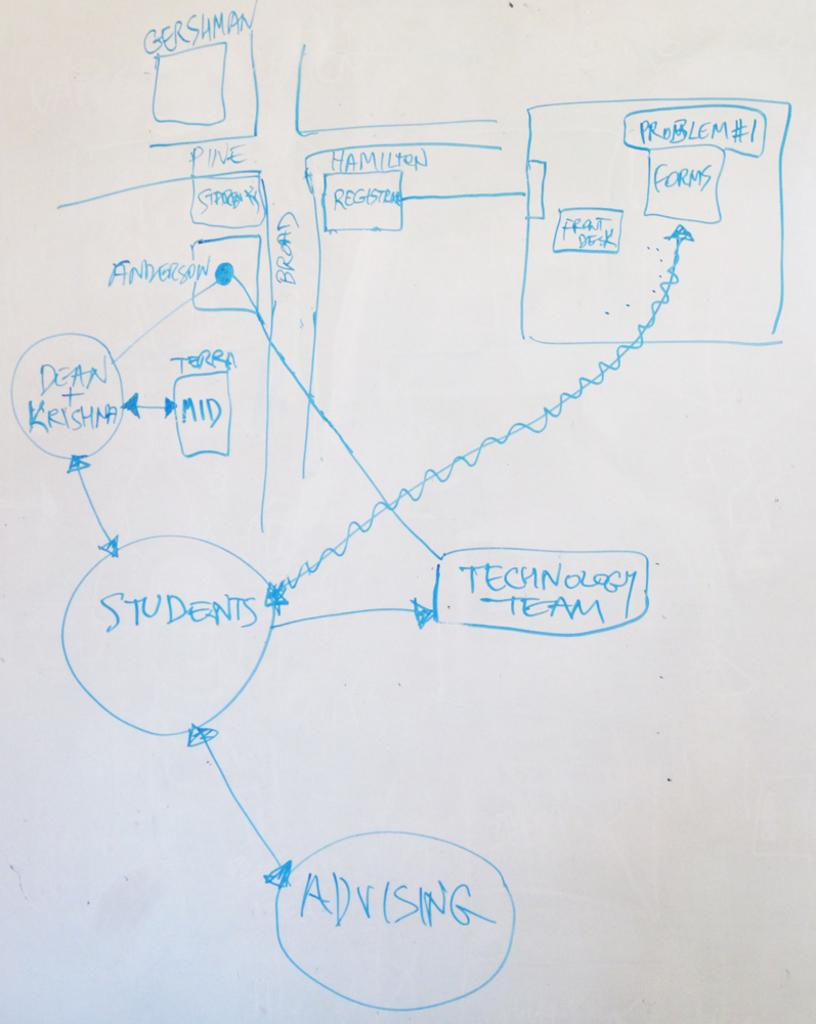Provide a one-sentence caption for the provided image. A drawing of the intersection of Pine and Broad and that shows what happens in the buildings around there. 